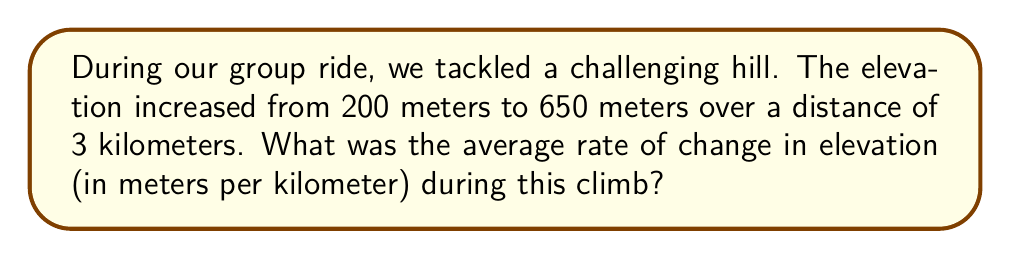Can you solve this math problem? Let's approach this step-by-step:

1) First, we need to identify the key information:
   - Initial elevation: 200 meters
   - Final elevation: 650 meters
   - Distance covered: 3 kilometers

2) To find the rate of change, we use the formula:
   
   $$ \text{Rate of change} = \frac{\text{Change in elevation}}{\text{Change in distance}} $$

3) Calculate the change in elevation:
   $$ \text{Change in elevation} = \text{Final elevation} - \text{Initial elevation} $$
   $$ = 650 \text{ m} - 200 \text{ m} = 450 \text{ m} $$

4) We already know the change in distance is 3 km.

5) Now, let's plug these values into our rate of change formula:
   
   $$ \text{Rate of change} = \frac{450 \text{ m}}{3 \text{ km}} = 150 \text{ m/km} $$

Therefore, the average rate of change in elevation during the climb was 150 meters per kilometer.
Answer: 150 m/km 